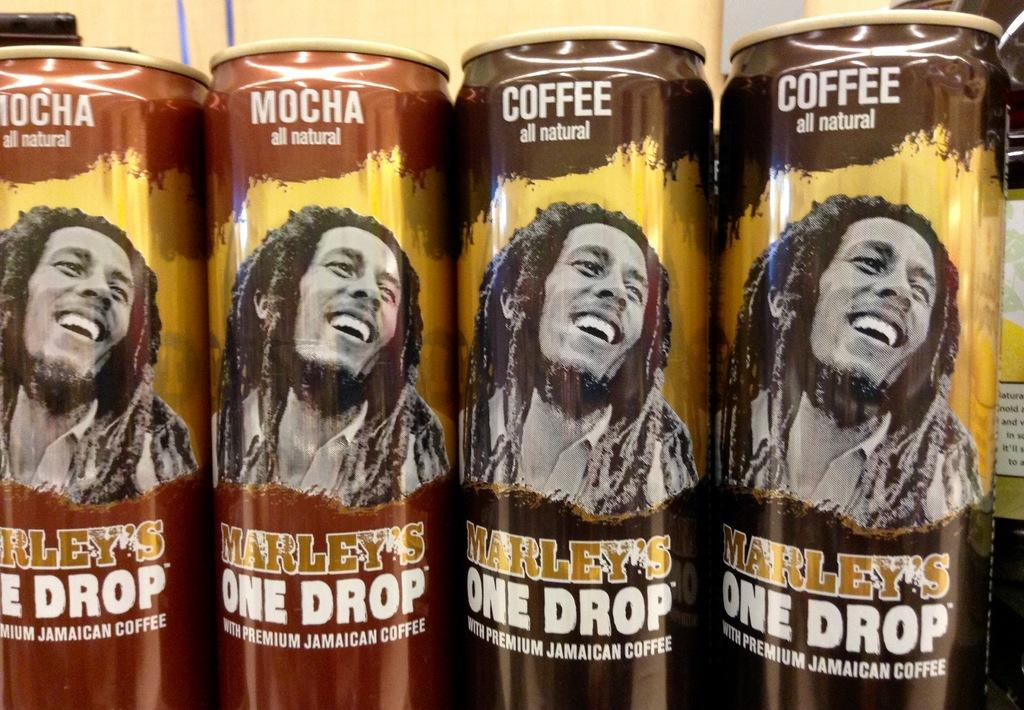<image>
Write a terse but informative summary of the picture. Several cans of Marley's One Drop coffees are lined up in a row. 